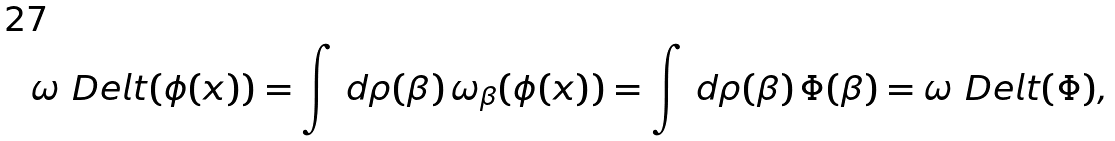<formula> <loc_0><loc_0><loc_500><loc_500>\omega _ { \ } D e l t ( \phi ( x ) ) = \int \, d \rho ( \beta ) \, \omega _ { \beta } ( \phi ( x ) ) = \int \, d \rho ( \beta ) \, \Phi ( \beta ) = \omega _ { \ } D e l t ( \Phi ) ,</formula> 